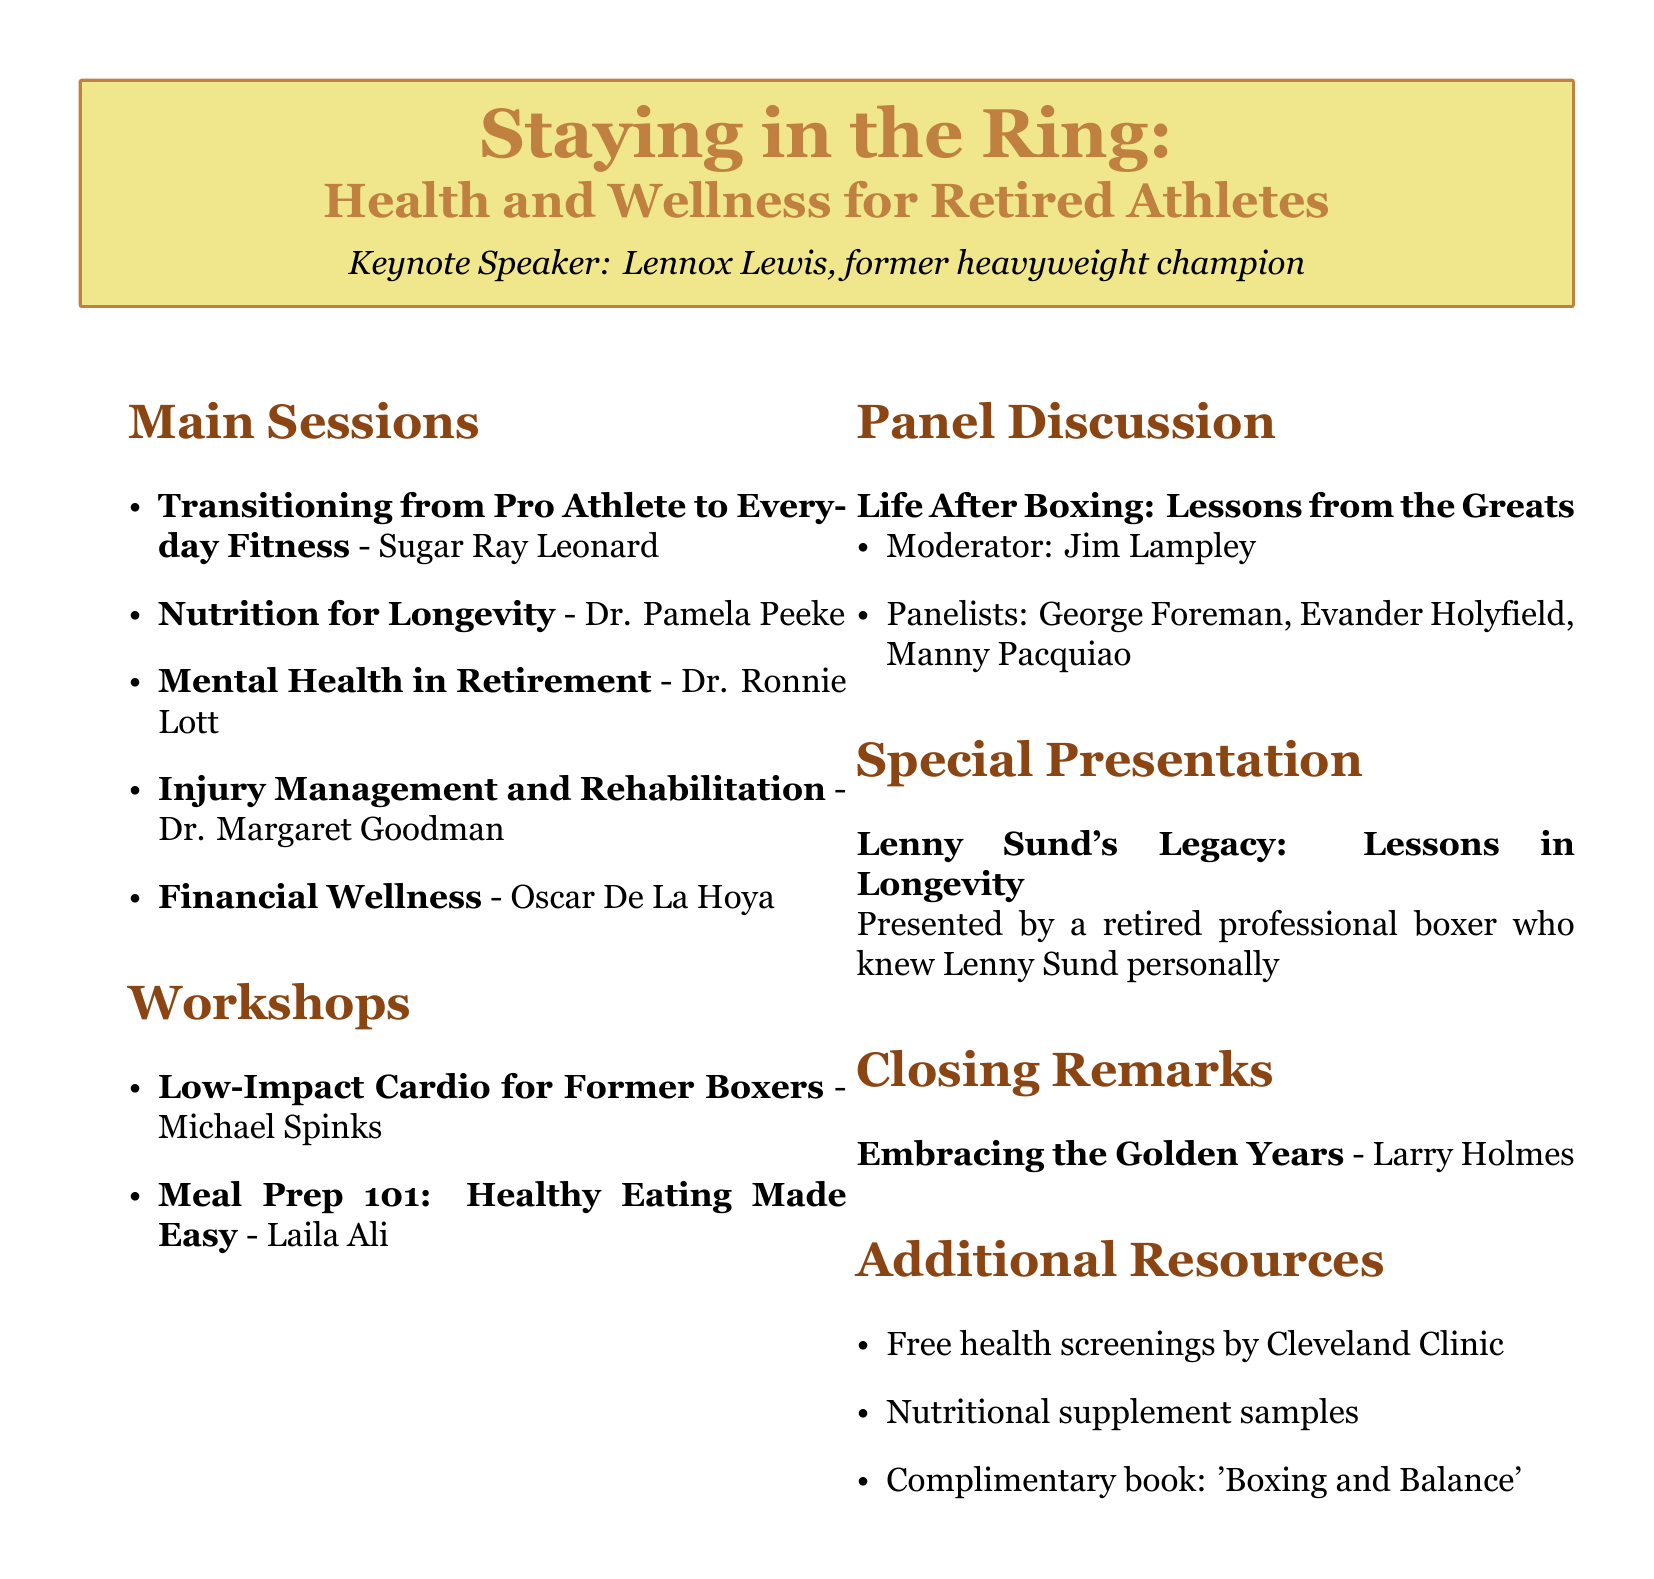What is the title of the seminar? The title is specifically mentioned at the beginning of the document as a key identifier.
Answer: Staying in the Ring: Health and Wellness for Retired Athletes Who is the keynote speaker? The keynote speaker's name is highlighted in the event details section, indicating their importance.
Answer: Lennox Lewis What is the first session about? The first session's title and description are provided in the main sessions section, outlining its focus.
Answer: Transitioning from Pro Athlete to Everyday Fitness Who is presenting the special presentation? The special presentation section specifies who is giving this talk.
Answer: YOU How many main sessions are there? The number of main sessions can be counted in the respective section of the document.
Answer: Five Who is the moderator of the panel discussion? The panel discussion section clearly states who will moderate the event.
Answer: Jim Lampley What is the topic of the closing remarks? The closing remarks topic summarizes the focus of the final thoughts shared at the seminar.
Answer: Embracing the Golden Years: Staying Active and Engaged in Retirement What type of resources are offered as additional resources? This can be determined by looking at the additional resources section that lists what will be available to participants.
Answer: Health screenings, nutritional supplement samples, complimentary book What is the instructor's name for the meal prep workshop? The instructor's name is made clear in the workshop sessions section describing the workshop's focus.
Answer: Laila Ali 